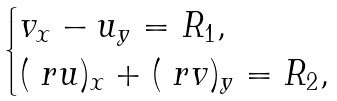Convert formula to latex. <formula><loc_0><loc_0><loc_500><loc_500>\begin{cases} v _ { x } - u _ { y } = R _ { 1 } , \\ ( \ r u ) _ { x } + ( \ r v ) _ { y } = R _ { 2 } , \end{cases}</formula> 